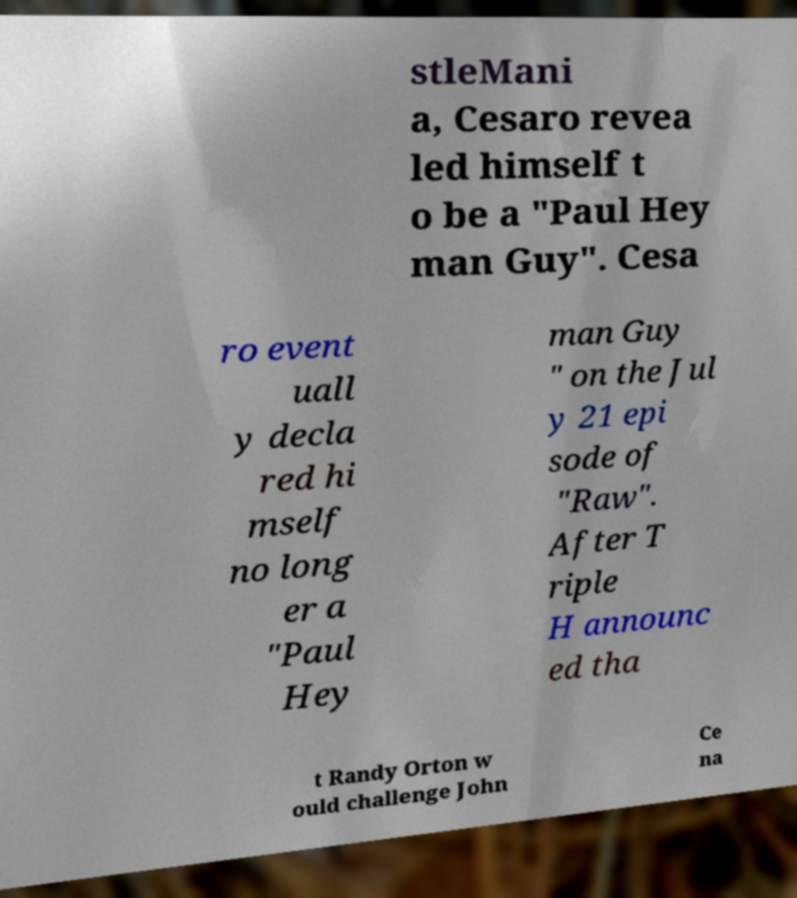There's text embedded in this image that I need extracted. Can you transcribe it verbatim? stleMani a, Cesaro revea led himself t o be a "Paul Hey man Guy". Cesa ro event uall y decla red hi mself no long er a "Paul Hey man Guy " on the Jul y 21 epi sode of "Raw". After T riple H announc ed tha t Randy Orton w ould challenge John Ce na 